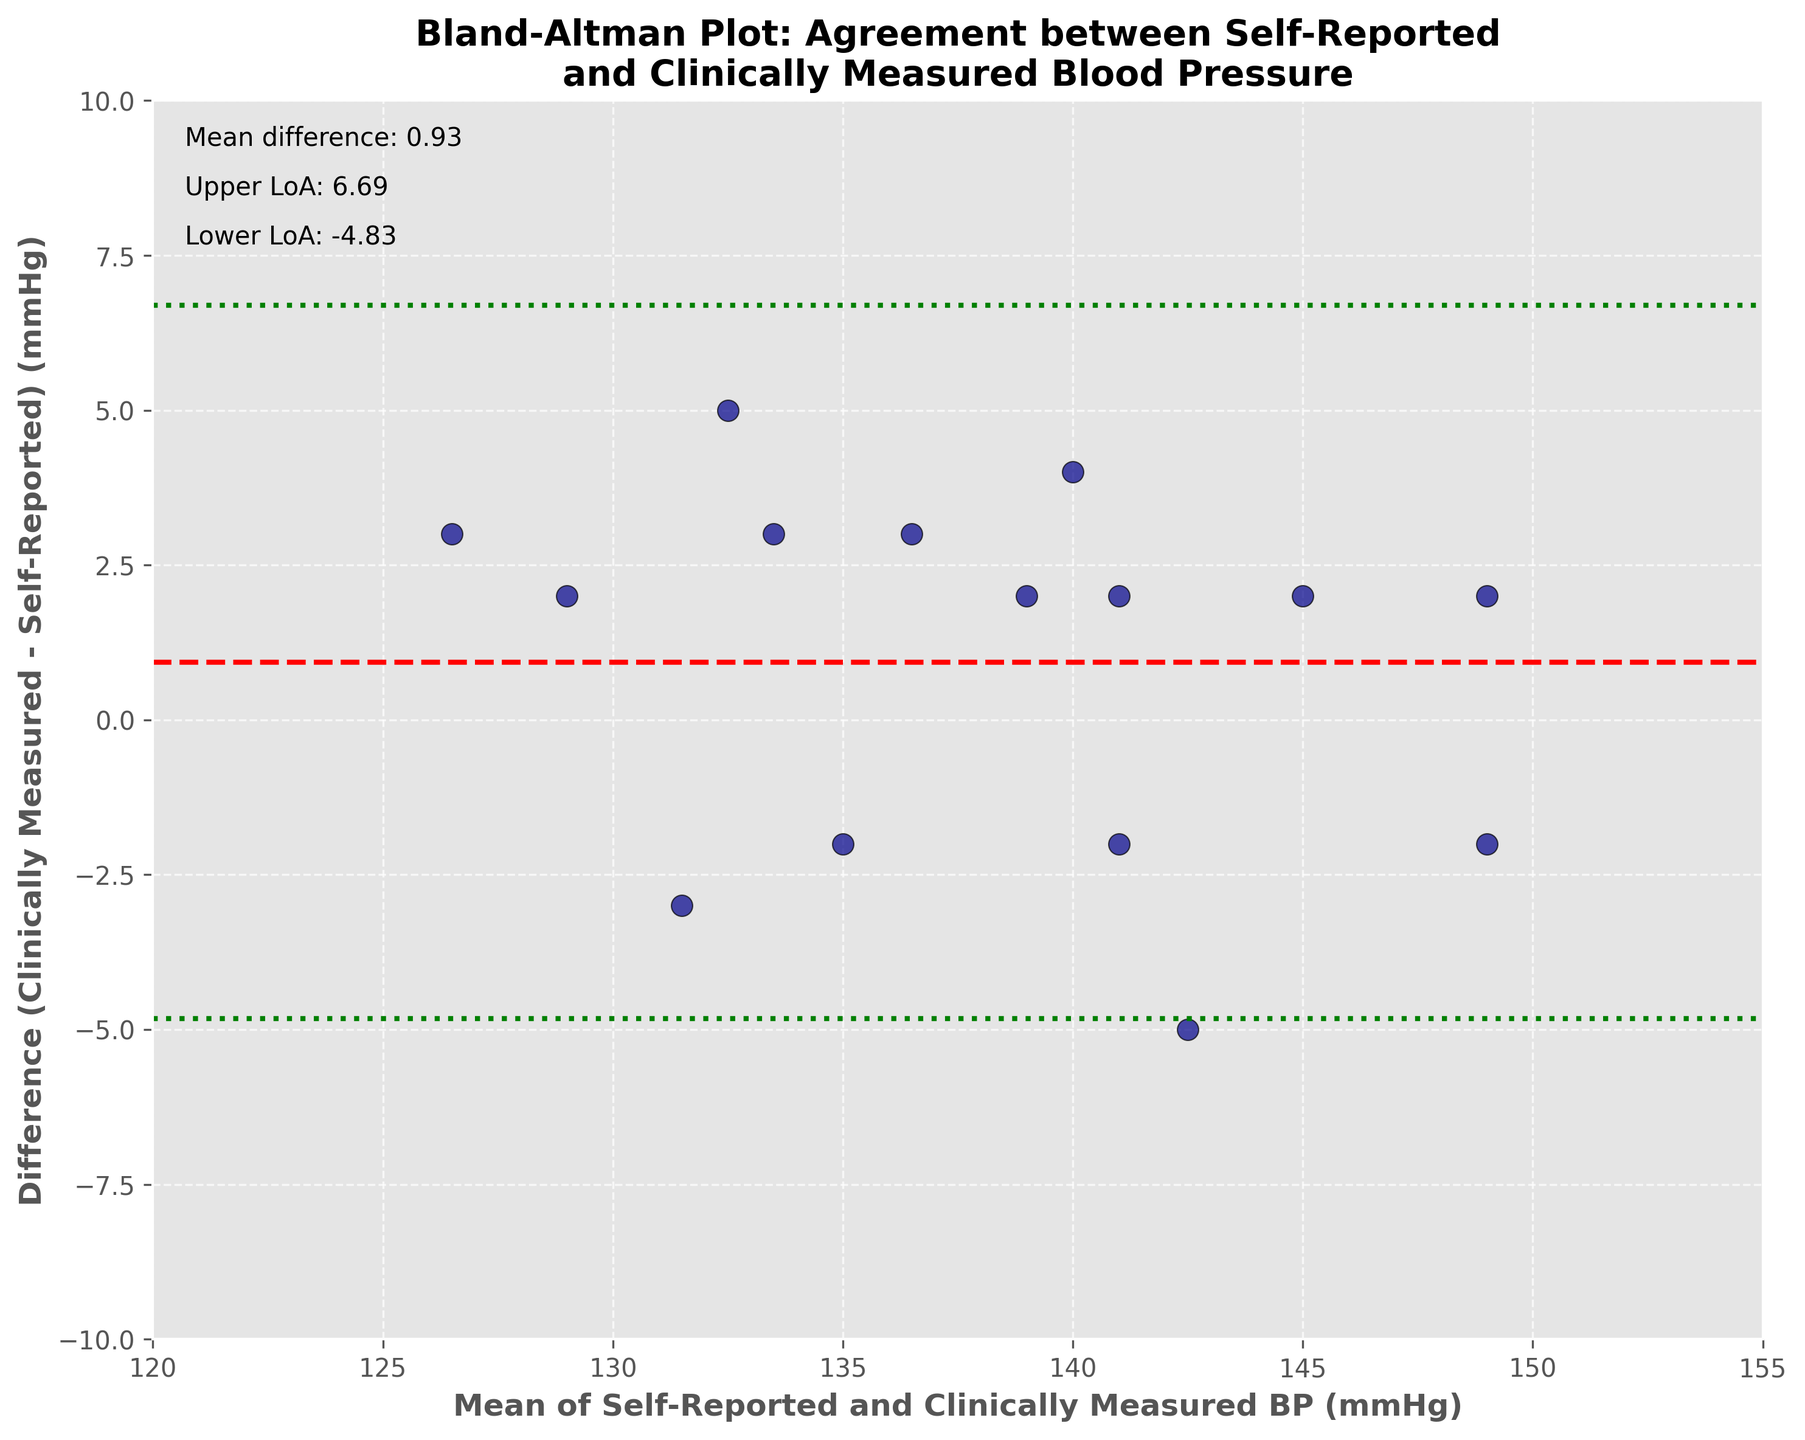What is the title of the plot? The title is usually located at the top of the figure and gives an overview of what the plot is about. In this case, it reads: "Bland-Altman Plot: Agreement between Self-Reported and Clinically Measured Blood Pressure."
Answer: Bland-Altman Plot: Agreement between Self-Reported and Clinically Measured Blood Pressure What do the x-axis and y-axis represent? The x-axis represents the "Mean of Self-Reported and Clinically Measured BP (mmHg)," while the y-axis represents the "Difference (Clinically Measured - Self-Reported) (mmHg)." These labels are directly indicated near the axes in the figure.
Answer: Mean of Self-Reported and Clinically Measured BP (x-axis) and Difference (Clinically Measured - Self-Reported) (y-axis) How many data points are plotted? The number of data points corresponds to the number of scatter points shown on the plot. You can count the individual points to determine the total number.
Answer: 15 What color and shape are the scatter points? The color of the scatter points is dark blue, and the shape is circular. This can be observed directly from the scatter plot.
Answer: Dark blue and circular What is the mean difference between clinically measured and self-reported blood pressure? The mean difference usually appears as a dashed line on the plot and is annotated with text. According to the annotations, the mean difference is displayed on the plot.
Answer: 0.8 What are the upper and lower limits of agreement? The plot includes dotted lines to represent the limits of agreement, usually annotated with text for easier identification. The upper limit is often higher than the mean difference, and the lower limit is lower. The plot annotations show these values.
Answer: Upper: 5.65, Lower: -4.05 Which data point has the maximum positive difference between clinically measured and self-reported blood pressure? You can identify the maximum positive difference by looking for the scatter point that is the highest on the y-axis. Upon closely observing the plotting area, this data point appears to be associated with Emmanuel Mkenda (Difference: 4).
Answer: Emmanuel Mkenda What is the range of the x-axis, and what does it imply about the data? The x-axis limits can be read from the axis itself, usually indicated by the minimum and maximum values shown. In this instance, the x-axis ranges from 120 to 155. This range implies that the mean blood pressure values lie within this interval.
Answer: 120 to 155 Are there any outliers in the plot? If so, which data points are they? Outliers are usually points that lie outside the limits of agreement or are far from the mean difference line. In the given figure, no data points lie outside the limits of agreement, thus implying the absence of outliers.
Answer: No outliers Is the mean clinically measured blood pressure higher or lower than the mean self-reported blood pressure? The overall trend in the mean difference and its position relative to zero can help us infer whether clinically measured values are generally higher or lower. The mean difference is slightly positive (0.8), indicating that clinically measured blood pressure tends to be slightly higher on average.
Answer: Higher 